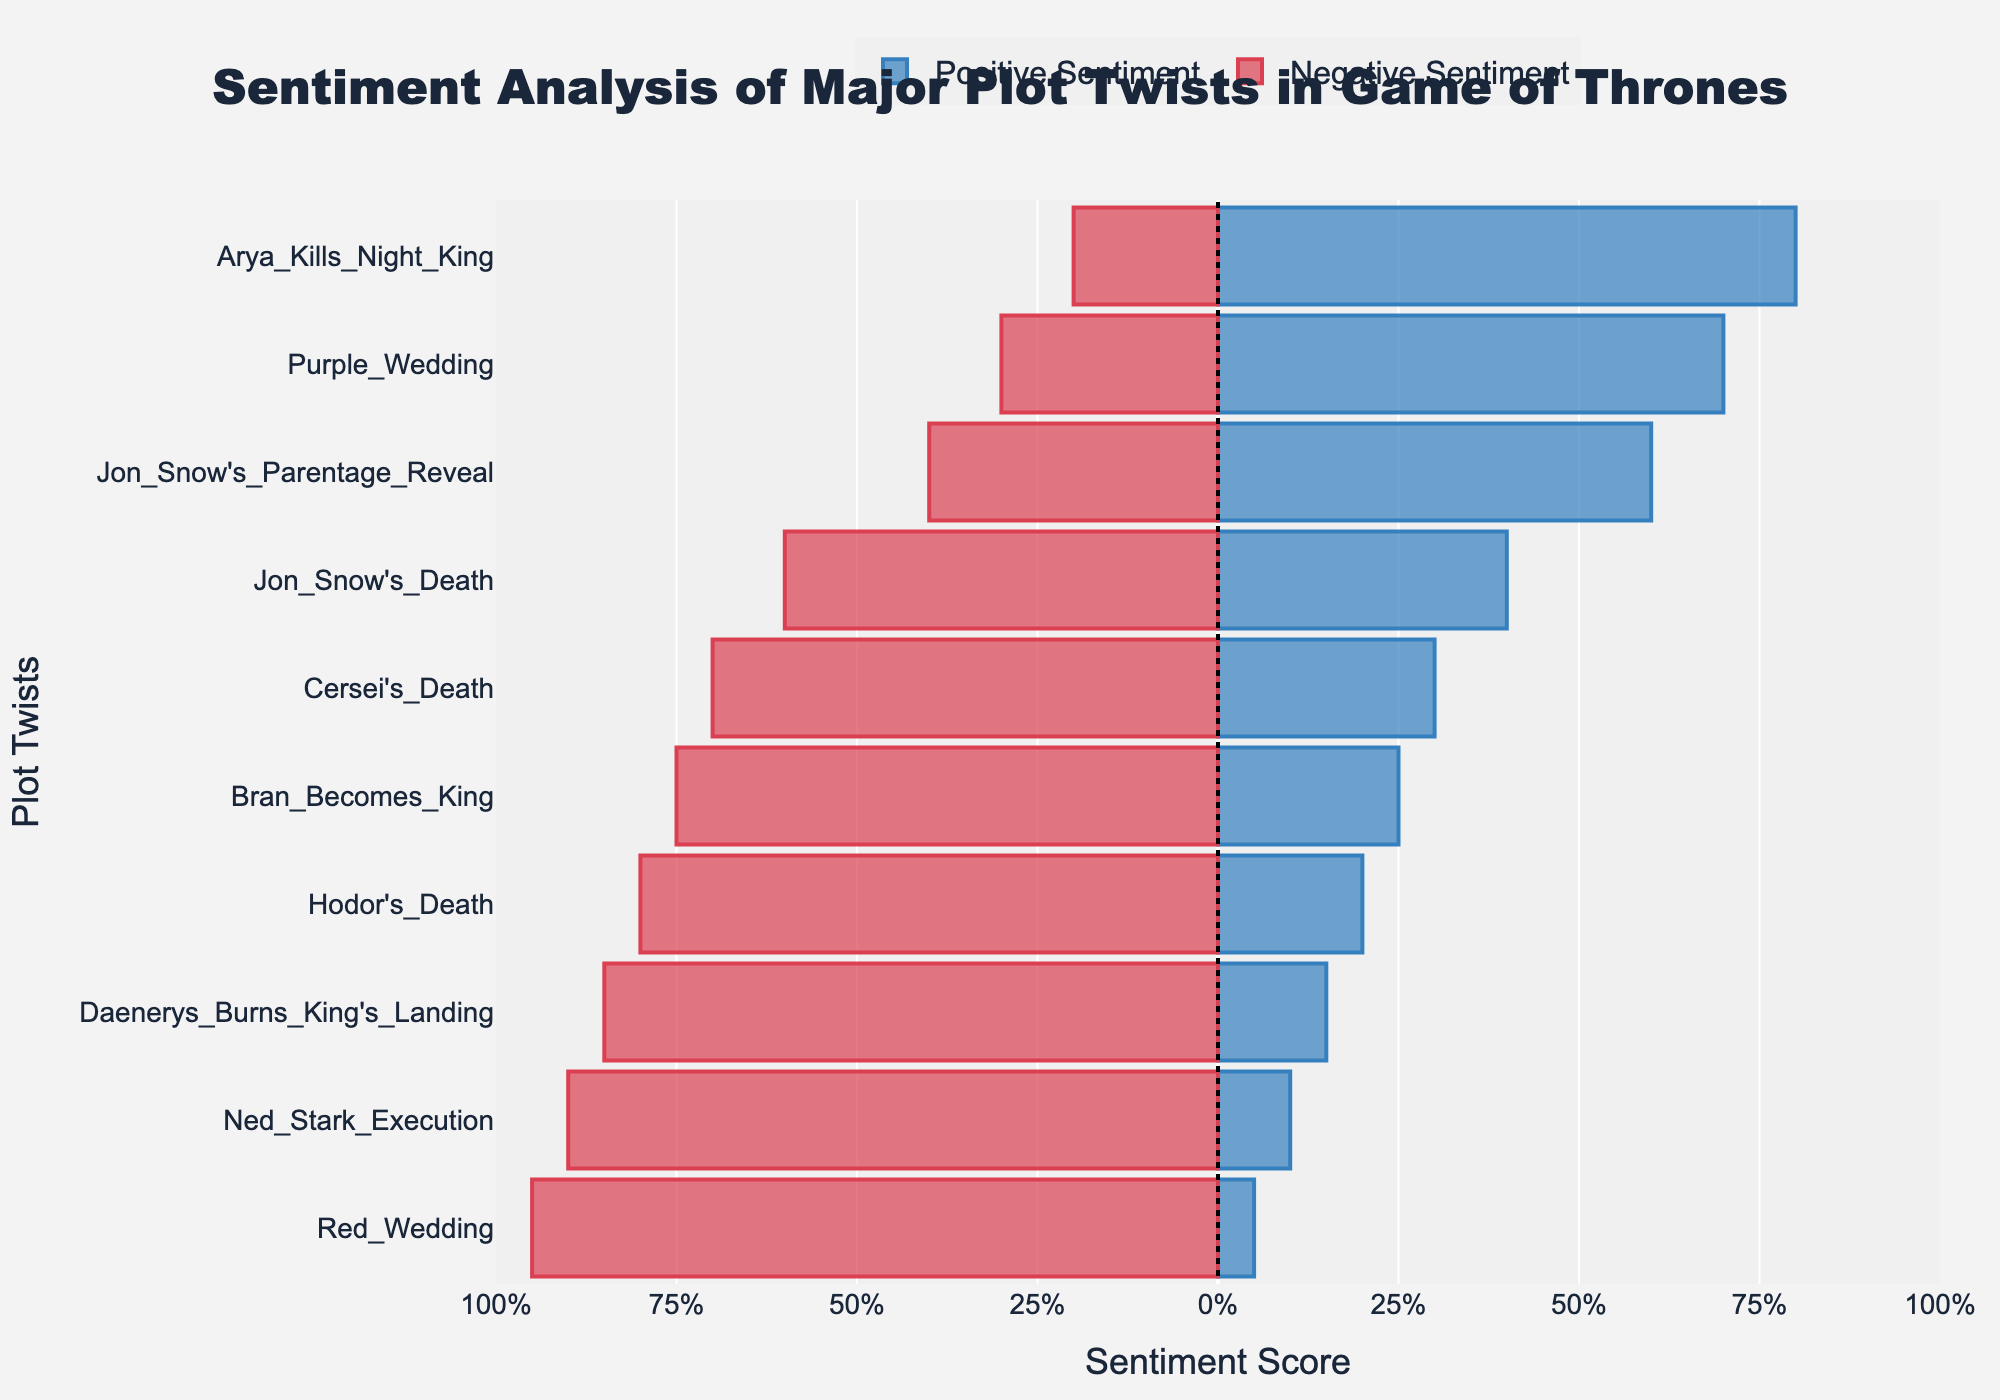Which plot twist had the highest positive sentiment? Look for the bar representing the highest positive sentiment score. "Arya Kills Night King" has the highest with a score of 80%.
Answer: Arya Kills Night King Which plot twist had the most negative sentiment? Look for the bar representing the highest negative sentiment score. "Red Wedding" has the highest with a score of 95%.
Answer: Red Wedding What is the difference between the positive and negative sentiment for "Jon Snow's Parentage Reveal"? Positive sentiment is 60% and negative sentiment is 40%. The difference is 60% - 40% = 20%.
Answer: 20% Which plot twist had the closest to equal positive and negative sentiment? Compare the percentages of positive and negative sentiment for each plot twist. "Jon Snow's Death" (40% positive, 60% negative) has the closest ratio with a difference of 20%.
Answer: Jon Snow's Death How does the sentiment for "Ned Stark Execution" compare to "Daenerys Burns King's Landing"? "Ned Stark Execution" has a positive sentiment of 10% and negative of 90%, while "Daenerys Burns King's Landing" has a positive sentiment of 15% and negative of 85%. "Ned Stark Execution" has 5% less positive sentiment and 5% more negative sentiment compared to "Daenerys Burns King's Landing".
Answer: Ned Stark Execution has less positive sentiment Which plot twist has the second highest positive sentiment? After "Arya Kills Night King" with 80%, "Jon Snow's Parentage Reveal" has the second highest positive sentiment with 60%.
Answer: Jon Snow's Parentage Reveal How many plot twists have more than 50% negative sentiment? Count the plot twists with negative sentiment scores greater than 50%. They are: Ned Stark Execution, Red Wedding, Jon Snow's Death, Hodor's Death, Daenerys Burns King's Landing, Bran Becomes King, and Cersei's Death (7 plot twists).
Answer: 7 Compare the positive sentiment of "Bran Becomes King" to "Purple Wedding". Which one had a higher value and by how much? "Bran Becomes King" has a positive sentiment of 25%, while "Purple Wedding" has 70%. The difference is 70% - 25% = 45%.
Answer: Purple Wedding by 45% What is the total sentiment score (positive and negative) for "Red Wedding"? Add the positive (5%) and negative (95%) sentiment scores. 5% + 95% = 100%.
Answer: 100% How does the length of the red bar for "Red Wedding" compare to "Cersei's Death"? "Red Wedding" has a negative sentiment of 95%, while "Cersei's Death" has 70%. "Red Wedding's" red bar is longer by 25%.
Answer: Red Wedding's bar is longer by 25% 